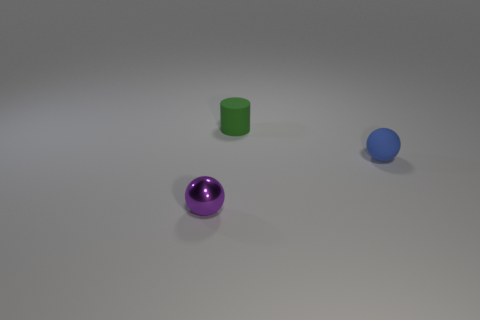There is a object that is in front of the small blue sphere; how many tiny things are right of it? While the purple sphere appears to be the closest to the point of view, assuming 'in front of' the blue sphere implies closest to the viewer, there are no tiny objects immediately to the right of the blue sphere. However, there is a green cylinder to the right and slightly behind the blue sphere, if we're considering the entire right half from the perspective of the viewpoint. 